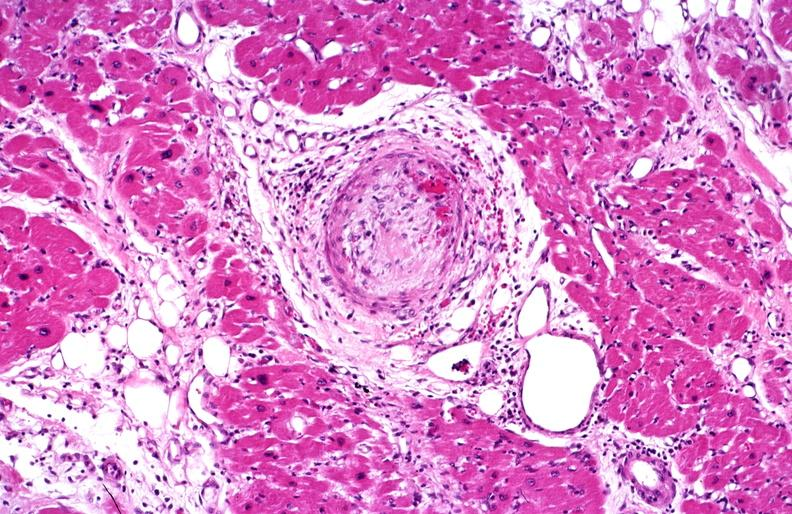s cardiovascular present?
Answer the question using a single word or phrase. Yes 